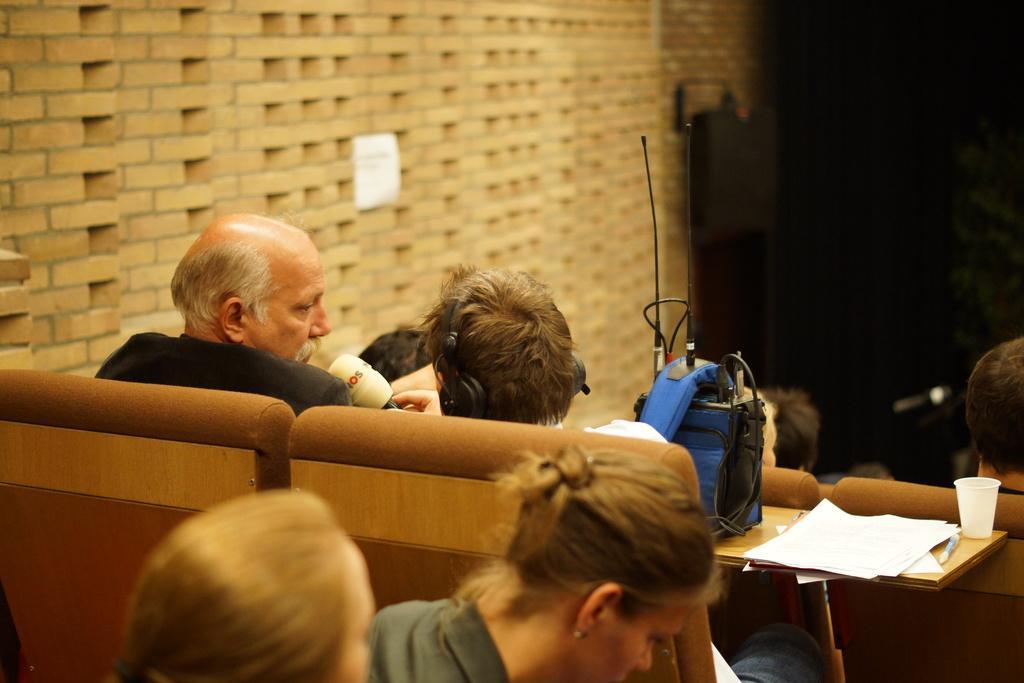In one or two sentences, can you explain what this image depicts? There are few people sitting on the chairs. This is a table with papers,glass and blue color bag placed on it. This is a wall with bricks. Background looks dark. 